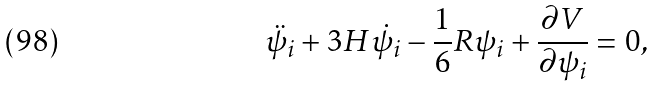<formula> <loc_0><loc_0><loc_500><loc_500>\ddot { \psi } _ { i } + 3 H \dot { \psi } _ { i } - \frac { 1 } { 6 } R \psi _ { i } + \frac { \partial V } { \partial \psi _ { i } } = 0 ,</formula> 